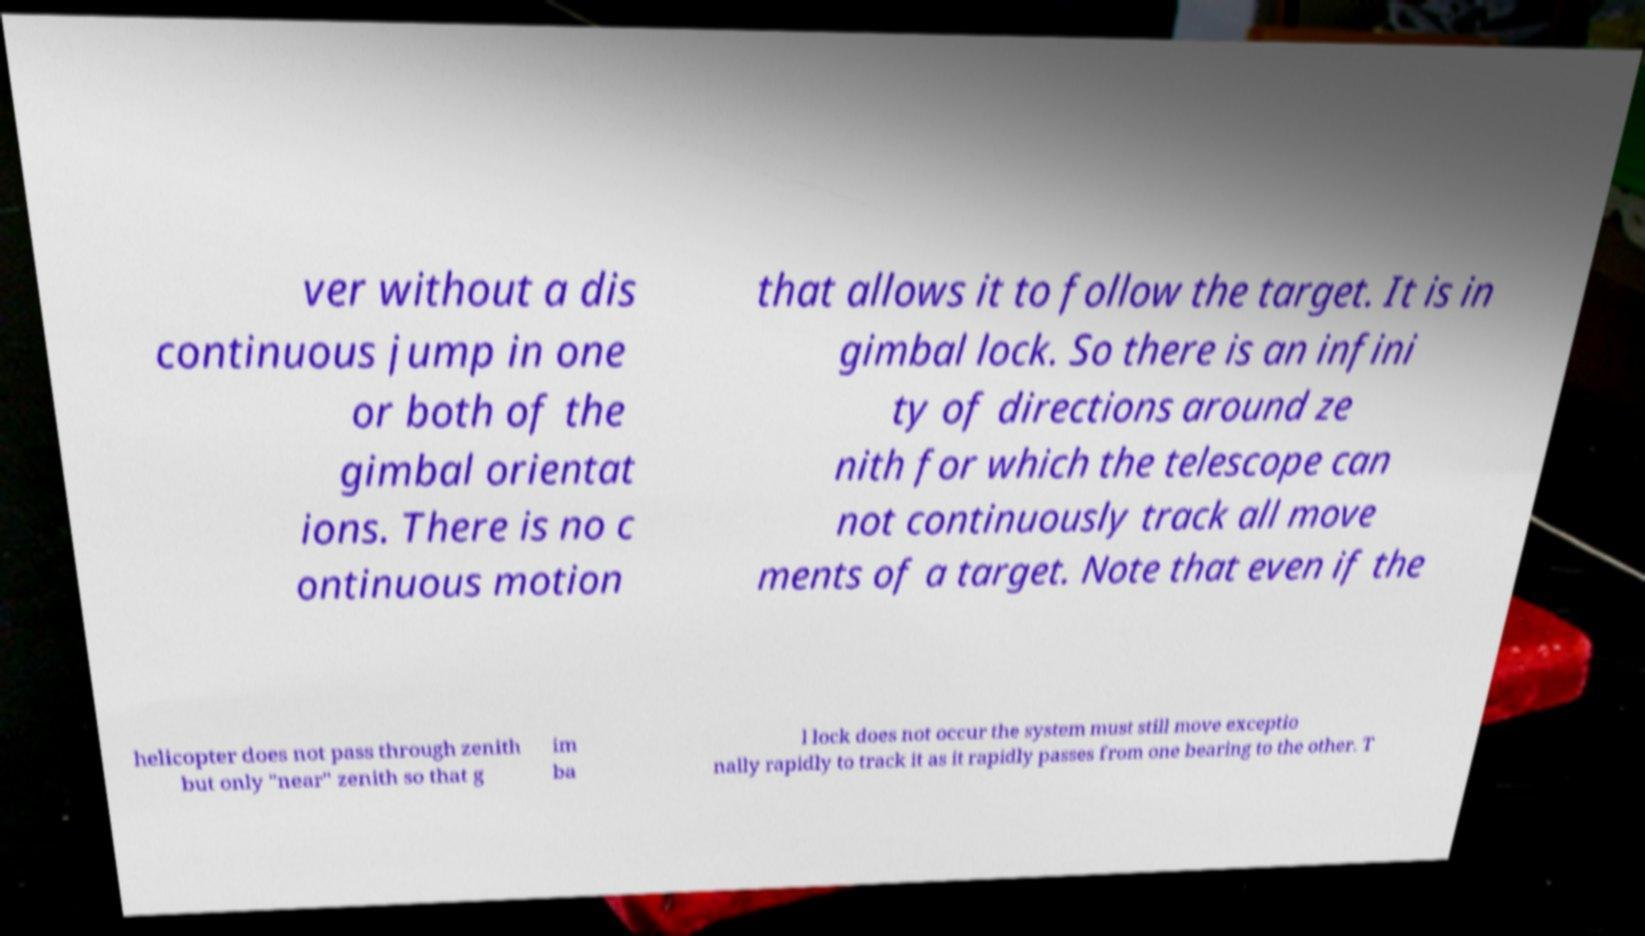I need the written content from this picture converted into text. Can you do that? ver without a dis continuous jump in one or both of the gimbal orientat ions. There is no c ontinuous motion that allows it to follow the target. It is in gimbal lock. So there is an infini ty of directions around ze nith for which the telescope can not continuously track all move ments of a target. Note that even if the helicopter does not pass through zenith but only "near" zenith so that g im ba l lock does not occur the system must still move exceptio nally rapidly to track it as it rapidly passes from one bearing to the other. T 